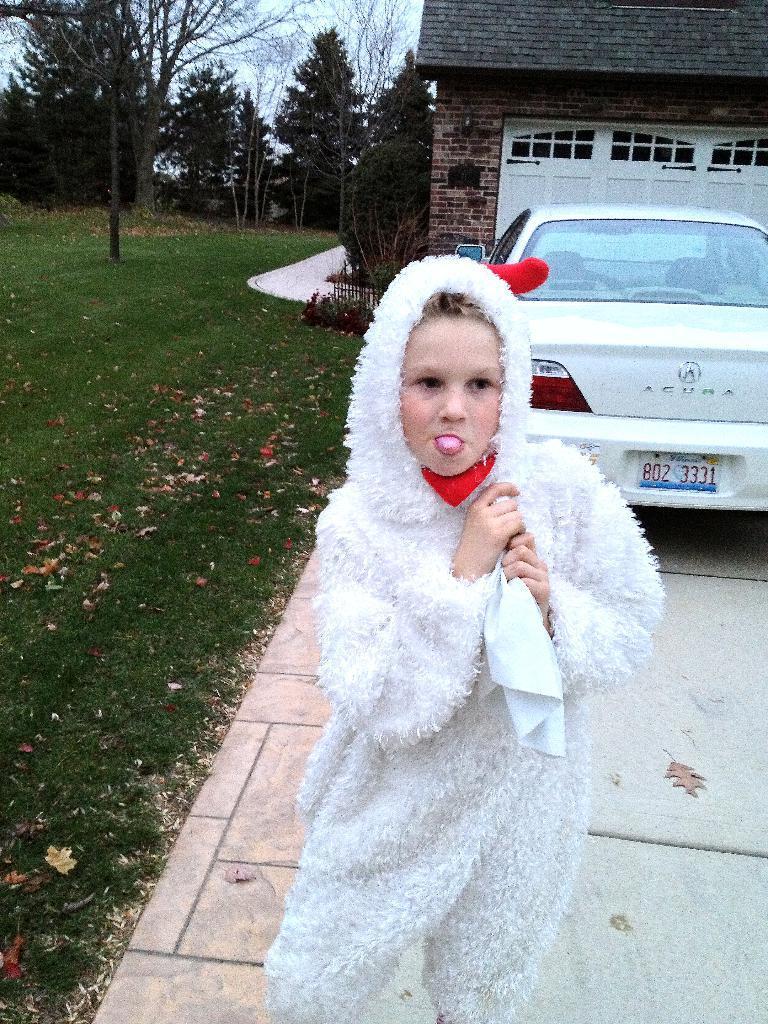Can you describe this image briefly? In the foreground I can see a kid on the road, grass and a car. In the background I can see a house, fence, house plants, trees and the sky. This image is taken may be during a day. 